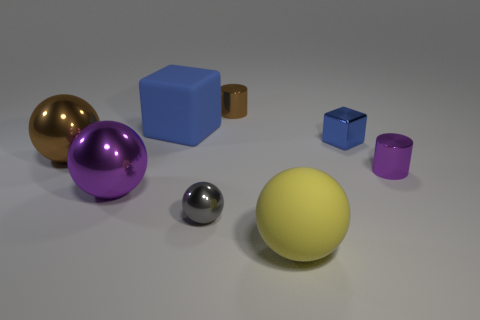Subtract all blue blocks. How many were subtracted if there are1blue blocks left? 1 Subtract all brown shiny spheres. How many spheres are left? 3 Subtract 0 red blocks. How many objects are left? 8 Subtract all cubes. How many objects are left? 6 Subtract 1 cylinders. How many cylinders are left? 1 Subtract all yellow blocks. Subtract all cyan spheres. How many blocks are left? 2 Subtract all gray cubes. How many red spheres are left? 0 Subtract all shiny cylinders. Subtract all large purple shiny objects. How many objects are left? 5 Add 1 blue rubber blocks. How many blue rubber blocks are left? 2 Add 5 blue objects. How many blue objects exist? 7 